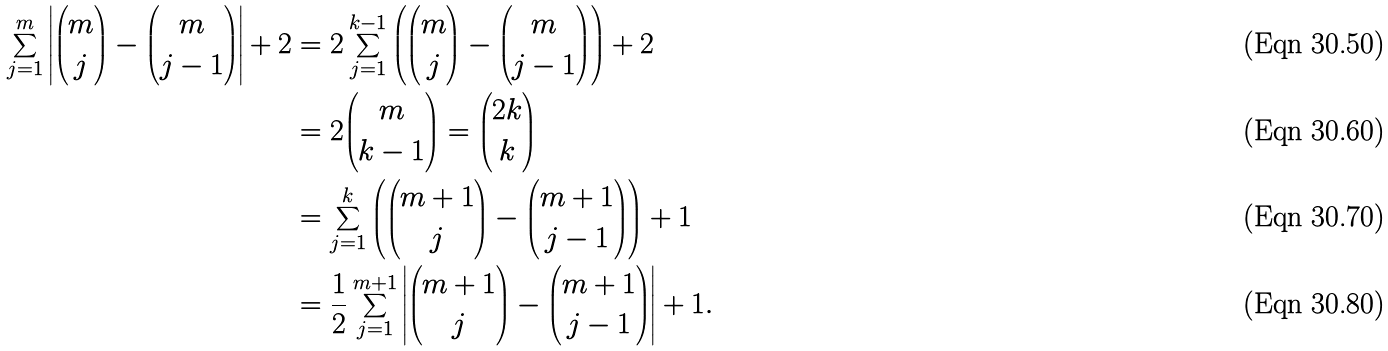Convert formula to latex. <formula><loc_0><loc_0><loc_500><loc_500>\sum _ { j = 1 } ^ { m } \left | \binom { m } { j } - \binom { m } { j - 1 } \right | + 2 & = 2 \sum _ { j = 1 } ^ { k - 1 } \left ( \binom { m } { j } - \binom { m } { j - 1 } \right ) + 2 \\ & = 2 \binom { m } { k - 1 } = \binom { 2 k } { k } \\ & = \sum _ { j = 1 } ^ { k } \left ( \binom { m + 1 } { j } - \binom { m + 1 } { j - 1 } \right ) + 1 \\ & = \frac { 1 } { 2 } \sum _ { j = 1 } ^ { m + 1 } \left | \binom { m + 1 } { j } - \binom { m + 1 } { j - 1 } \right | + 1 .</formula> 